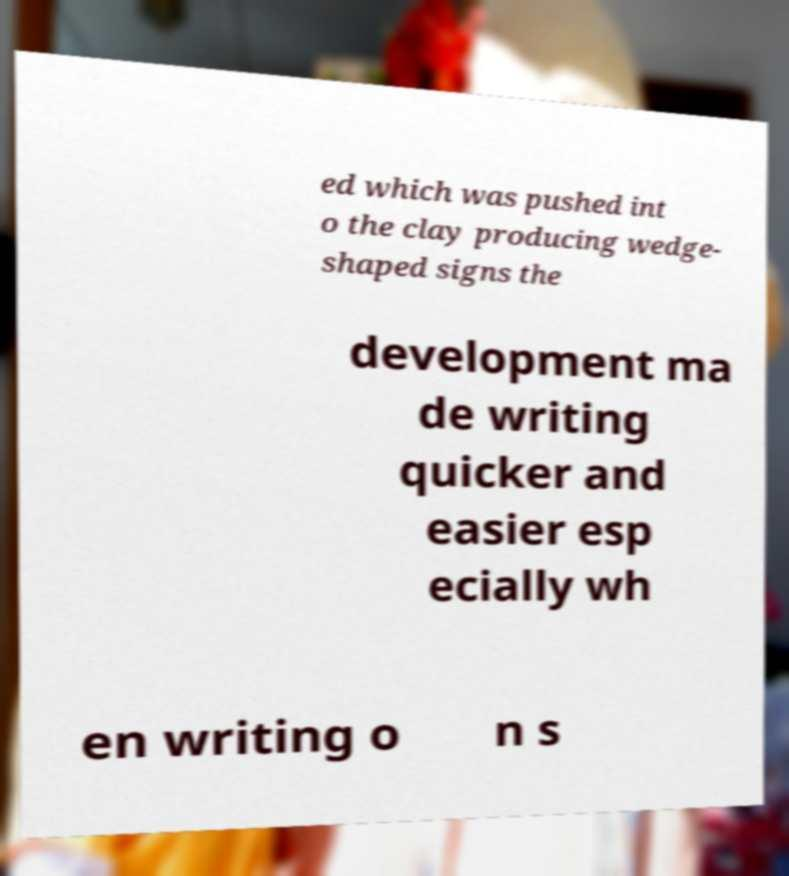What messages or text are displayed in this image? I need them in a readable, typed format. ed which was pushed int o the clay producing wedge- shaped signs the development ma de writing quicker and easier esp ecially wh en writing o n s 